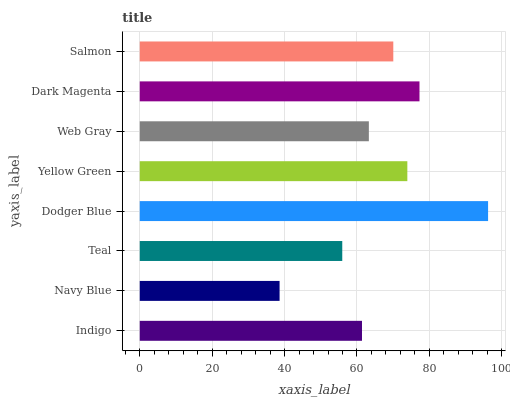Is Navy Blue the minimum?
Answer yes or no. Yes. Is Dodger Blue the maximum?
Answer yes or no. Yes. Is Teal the minimum?
Answer yes or no. No. Is Teal the maximum?
Answer yes or no. No. Is Teal greater than Navy Blue?
Answer yes or no. Yes. Is Navy Blue less than Teal?
Answer yes or no. Yes. Is Navy Blue greater than Teal?
Answer yes or no. No. Is Teal less than Navy Blue?
Answer yes or no. No. Is Salmon the high median?
Answer yes or no. Yes. Is Web Gray the low median?
Answer yes or no. Yes. Is Navy Blue the high median?
Answer yes or no. No. Is Salmon the low median?
Answer yes or no. No. 